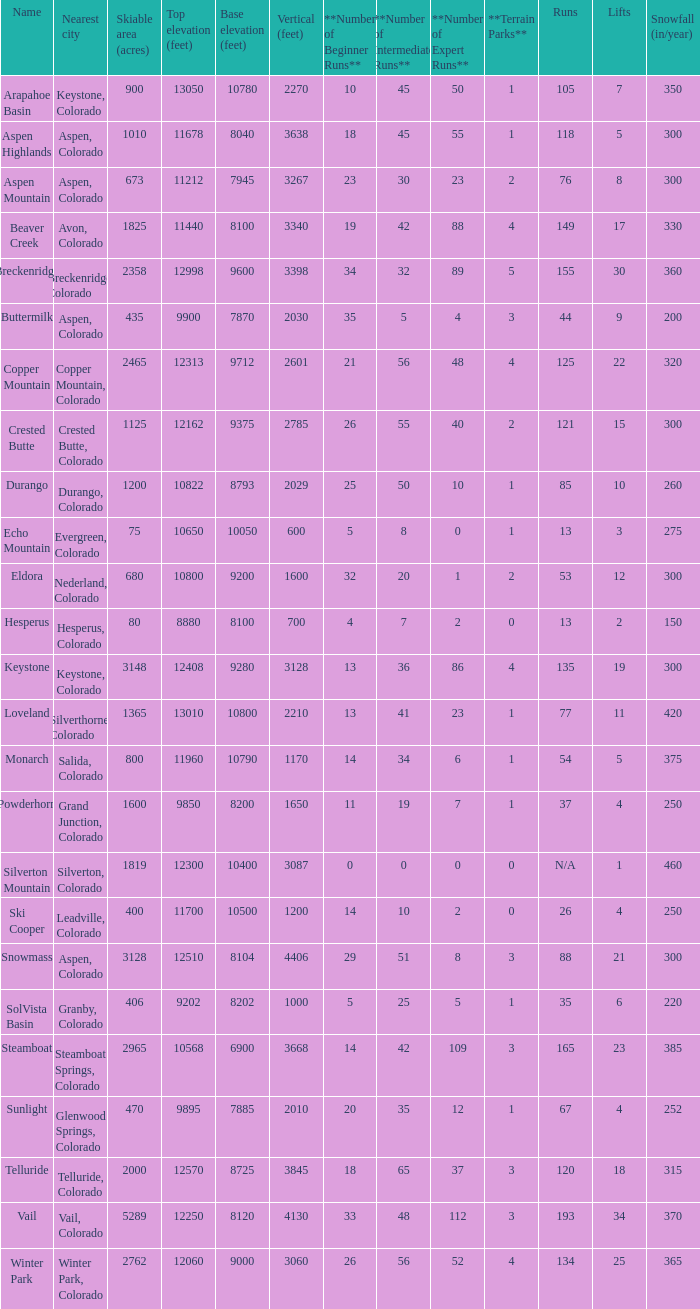If there are 11 lifts, what is the base elevation? 10800.0. 